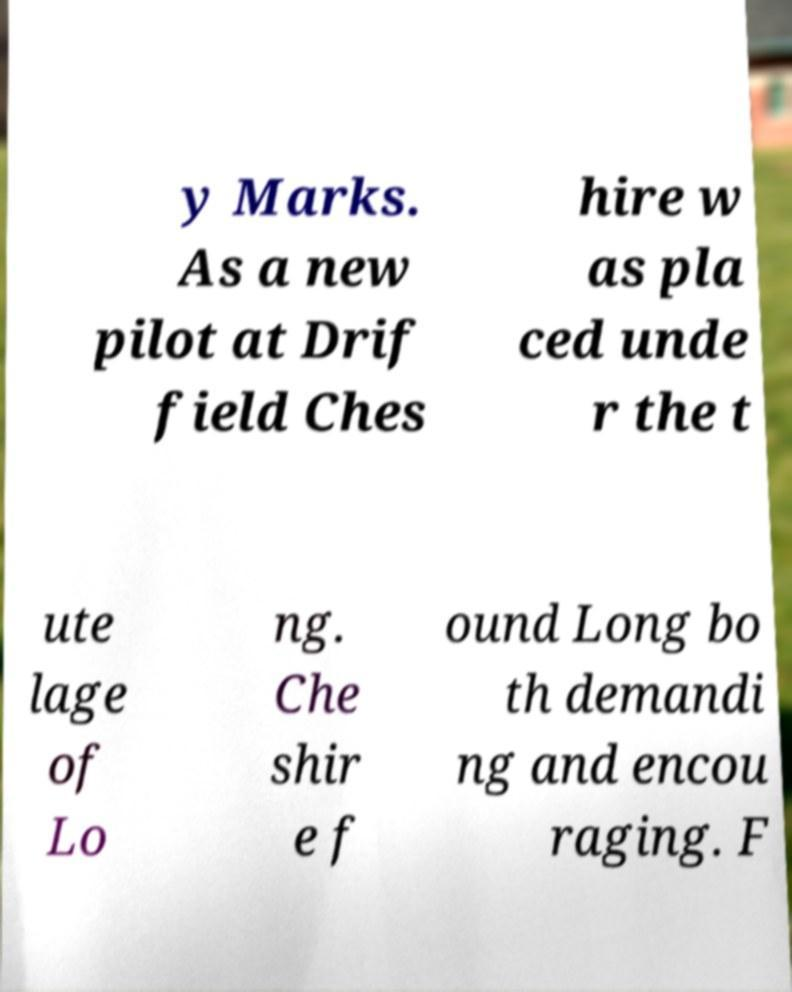Please read and relay the text visible in this image. What does it say? y Marks. As a new pilot at Drif field Ches hire w as pla ced unde r the t ute lage of Lo ng. Che shir e f ound Long bo th demandi ng and encou raging. F 